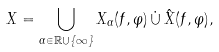Convert formula to latex. <formula><loc_0><loc_0><loc_500><loc_500>X = \bigcup _ { \alpha \in \mathbb { R } \cup \{ \infty \} } X _ { \alpha } ( f , \varphi ) \, \dot { \cup } \, \hat { X } ( f , \varphi ) ,</formula> 